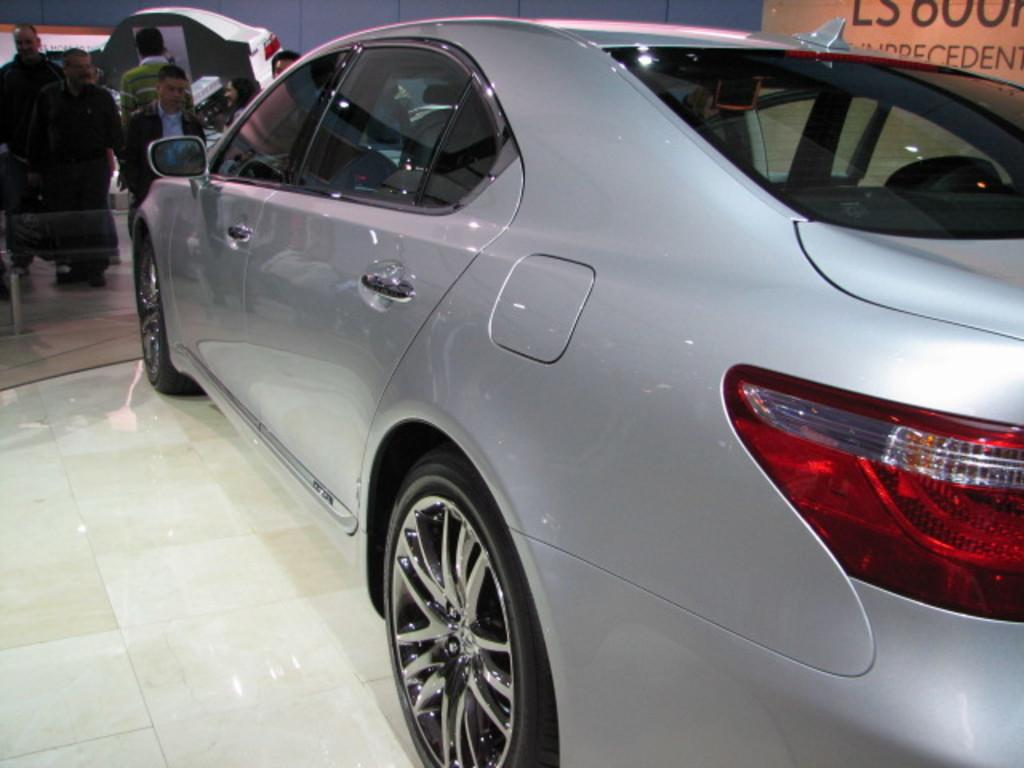What is the main subject of the image? There is a car in the image. What else can be seen in the image besides the car? There is a group of people standing on the floor. What is visible on the wall in the background of the image? There are banners on the wall in the background of the image. What type of stitch is used to create the sweater worn by the person in the image? There is no person wearing a sweater in the image, and therefore no stitch can be observed. How does the cough of the person in the image affect the surrounding environment? There is no person coughing in the image, so the cough cannot affect the environment. 